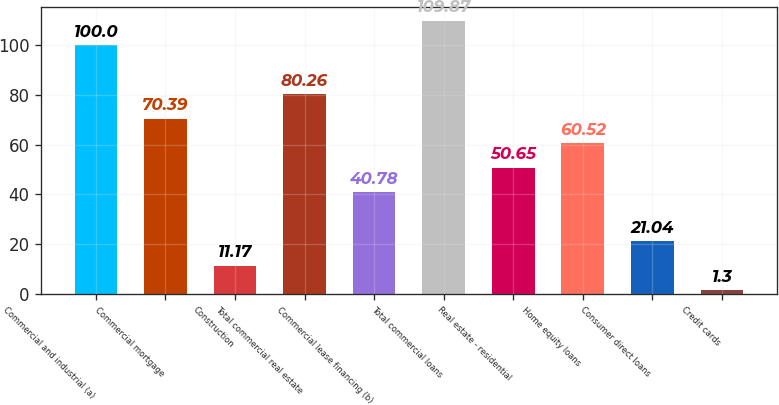Convert chart. <chart><loc_0><loc_0><loc_500><loc_500><bar_chart><fcel>Commercial and industrial (a)<fcel>Commercial mortgage<fcel>Construction<fcel>Total commercial real estate<fcel>Commercial lease financing (b)<fcel>Total commercial loans<fcel>Real estate - residential<fcel>Home equity loans<fcel>Consumer direct loans<fcel>Credit cards<nl><fcel>100<fcel>70.39<fcel>11.17<fcel>80.26<fcel>40.78<fcel>109.87<fcel>50.65<fcel>60.52<fcel>21.04<fcel>1.3<nl></chart> 